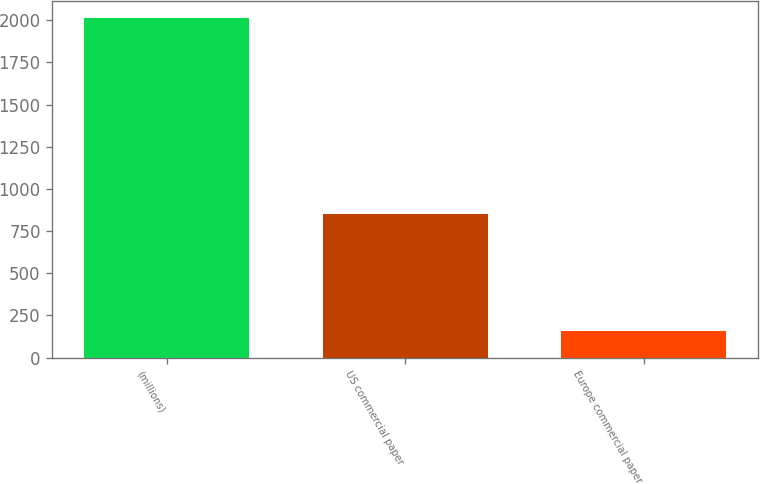Convert chart to OTSL. <chart><loc_0><loc_0><loc_500><loc_500><bar_chart><fcel>(millions)<fcel>US commercial paper<fcel>Europe commercial paper<nl><fcel>2012<fcel>853<fcel>159<nl></chart> 